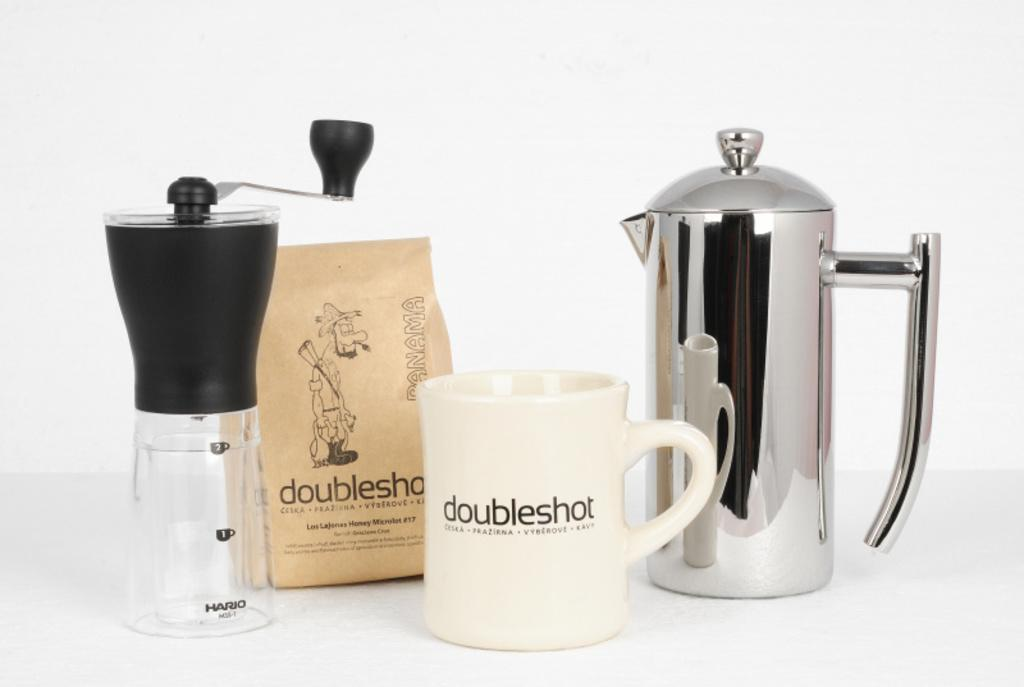<image>
Relay a brief, clear account of the picture shown. A mug that says doubleshot and other coffee products 